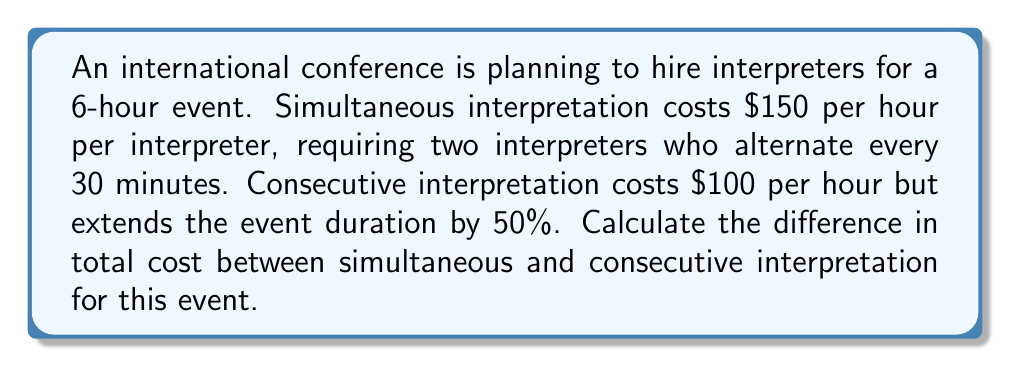Can you solve this math problem? Let's approach this step-by-step:

1) Simultaneous Interpretation:
   - Duration: 6 hours
   - Cost per hour: $150
   - Number of interpreters: 2
   - Total cost: $$ C_s = 6 \times 150 \times 2 = 1800 $$

2) Consecutive Interpretation:
   - Original duration: 6 hours
   - Extended duration: $$ 6 \times 1.5 = 9 $$ hours
   - Cost per hour: $100
   - Total cost: $$ C_c = 9 \times 100 = 900 $$

3) Difference in cost:
   $$ \Delta C = C_s - C_c = 1800 - 900 = 900 $$

Therefore, simultaneous interpretation costs $900 more than consecutive interpretation for this event.
Answer: $900 